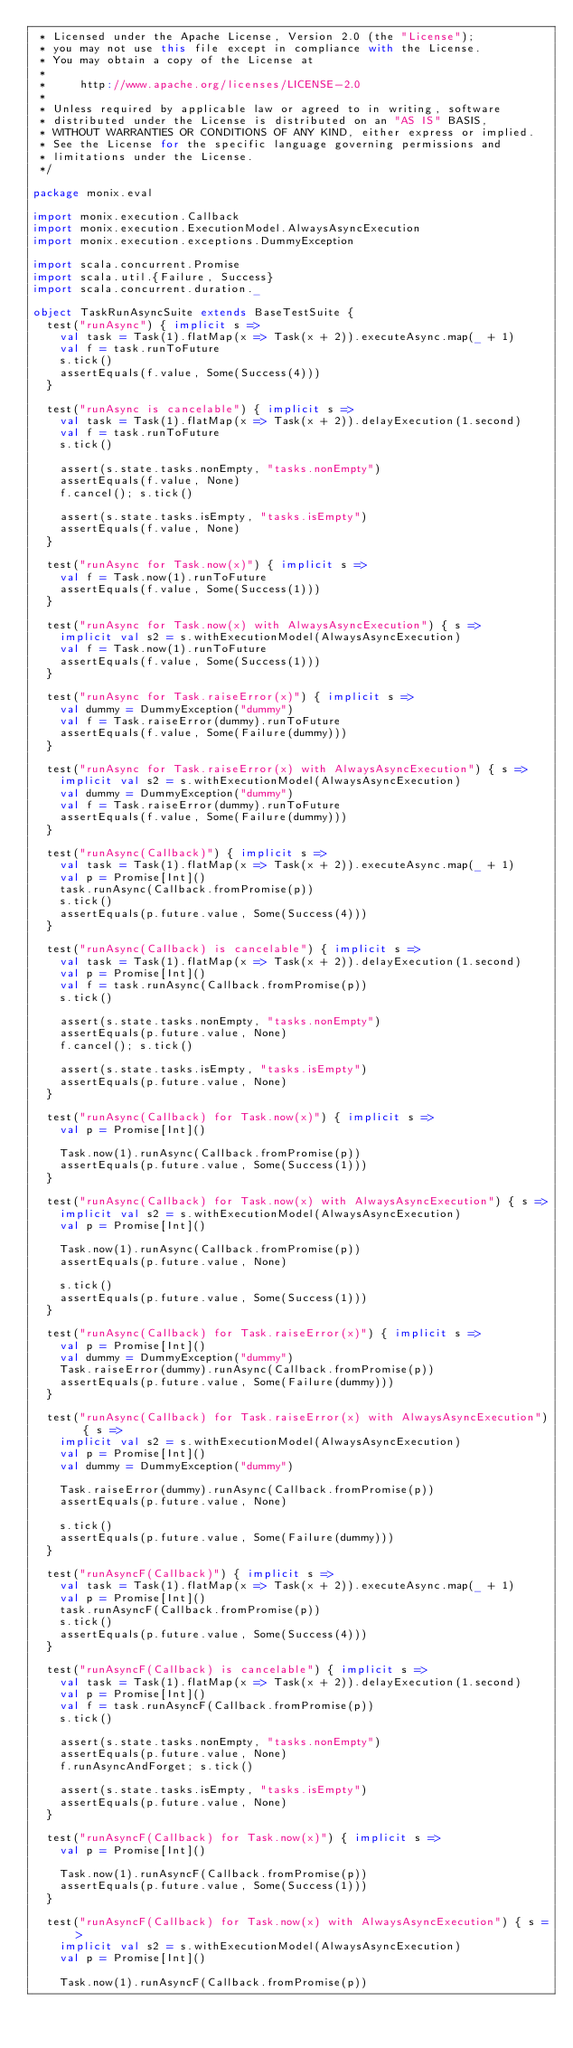Convert code to text. <code><loc_0><loc_0><loc_500><loc_500><_Scala_> * Licensed under the Apache License, Version 2.0 (the "License");
 * you may not use this file except in compliance with the License.
 * You may obtain a copy of the License at
 *
 *     http://www.apache.org/licenses/LICENSE-2.0
 *
 * Unless required by applicable law or agreed to in writing, software
 * distributed under the License is distributed on an "AS IS" BASIS,
 * WITHOUT WARRANTIES OR CONDITIONS OF ANY KIND, either express or implied.
 * See the License for the specific language governing permissions and
 * limitations under the License.
 */

package monix.eval

import monix.execution.Callback
import monix.execution.ExecutionModel.AlwaysAsyncExecution
import monix.execution.exceptions.DummyException

import scala.concurrent.Promise
import scala.util.{Failure, Success}
import scala.concurrent.duration._

object TaskRunAsyncSuite extends BaseTestSuite {
  test("runAsync") { implicit s =>
    val task = Task(1).flatMap(x => Task(x + 2)).executeAsync.map(_ + 1)
    val f = task.runToFuture
    s.tick()
    assertEquals(f.value, Some(Success(4)))
  }

  test("runAsync is cancelable") { implicit s =>
    val task = Task(1).flatMap(x => Task(x + 2)).delayExecution(1.second)
    val f = task.runToFuture
    s.tick()

    assert(s.state.tasks.nonEmpty, "tasks.nonEmpty")
    assertEquals(f.value, None)
    f.cancel(); s.tick()

    assert(s.state.tasks.isEmpty, "tasks.isEmpty")
    assertEquals(f.value, None)
  }

  test("runAsync for Task.now(x)") { implicit s =>
    val f = Task.now(1).runToFuture
    assertEquals(f.value, Some(Success(1)))
  }

  test("runAsync for Task.now(x) with AlwaysAsyncExecution") { s =>
    implicit val s2 = s.withExecutionModel(AlwaysAsyncExecution)
    val f = Task.now(1).runToFuture
    assertEquals(f.value, Some(Success(1)))
  }

  test("runAsync for Task.raiseError(x)") { implicit s =>
    val dummy = DummyException("dummy")
    val f = Task.raiseError(dummy).runToFuture
    assertEquals(f.value, Some(Failure(dummy)))
  }

  test("runAsync for Task.raiseError(x) with AlwaysAsyncExecution") { s =>
    implicit val s2 = s.withExecutionModel(AlwaysAsyncExecution)
    val dummy = DummyException("dummy")
    val f = Task.raiseError(dummy).runToFuture
    assertEquals(f.value, Some(Failure(dummy)))
  }

  test("runAsync(Callback)") { implicit s =>
    val task = Task(1).flatMap(x => Task(x + 2)).executeAsync.map(_ + 1)
    val p = Promise[Int]()
    task.runAsync(Callback.fromPromise(p))
    s.tick()
    assertEquals(p.future.value, Some(Success(4)))
  }

  test("runAsync(Callback) is cancelable") { implicit s =>
    val task = Task(1).flatMap(x => Task(x + 2)).delayExecution(1.second)
    val p = Promise[Int]()
    val f = task.runAsync(Callback.fromPromise(p))
    s.tick()

    assert(s.state.tasks.nonEmpty, "tasks.nonEmpty")
    assertEquals(p.future.value, None)
    f.cancel(); s.tick()

    assert(s.state.tasks.isEmpty, "tasks.isEmpty")
    assertEquals(p.future.value, None)
  }

  test("runAsync(Callback) for Task.now(x)") { implicit s =>
    val p = Promise[Int]()

    Task.now(1).runAsync(Callback.fromPromise(p))
    assertEquals(p.future.value, Some(Success(1)))
  }

  test("runAsync(Callback) for Task.now(x) with AlwaysAsyncExecution") { s =>
    implicit val s2 = s.withExecutionModel(AlwaysAsyncExecution)
    val p = Promise[Int]()

    Task.now(1).runAsync(Callback.fromPromise(p))
    assertEquals(p.future.value, None)

    s.tick()
    assertEquals(p.future.value, Some(Success(1)))
  }

  test("runAsync(Callback) for Task.raiseError(x)") { implicit s =>
    val p = Promise[Int]()
    val dummy = DummyException("dummy")
    Task.raiseError(dummy).runAsync(Callback.fromPromise(p))
    assertEquals(p.future.value, Some(Failure(dummy)))
  }

  test("runAsync(Callback) for Task.raiseError(x) with AlwaysAsyncExecution") { s =>
    implicit val s2 = s.withExecutionModel(AlwaysAsyncExecution)
    val p = Promise[Int]()
    val dummy = DummyException("dummy")

    Task.raiseError(dummy).runAsync(Callback.fromPromise(p))
    assertEquals(p.future.value, None)

    s.tick()
    assertEquals(p.future.value, Some(Failure(dummy)))
  }

  test("runAsyncF(Callback)") { implicit s =>
    val task = Task(1).flatMap(x => Task(x + 2)).executeAsync.map(_ + 1)
    val p = Promise[Int]()
    task.runAsyncF(Callback.fromPromise(p))
    s.tick()
    assertEquals(p.future.value, Some(Success(4)))
  }

  test("runAsyncF(Callback) is cancelable") { implicit s =>
    val task = Task(1).flatMap(x => Task(x + 2)).delayExecution(1.second)
    val p = Promise[Int]()
    val f = task.runAsyncF(Callback.fromPromise(p))
    s.tick()

    assert(s.state.tasks.nonEmpty, "tasks.nonEmpty")
    assertEquals(p.future.value, None)
    f.runAsyncAndForget; s.tick()

    assert(s.state.tasks.isEmpty, "tasks.isEmpty")
    assertEquals(p.future.value, None)
  }

  test("runAsyncF(Callback) for Task.now(x)") { implicit s =>
    val p = Promise[Int]()

    Task.now(1).runAsyncF(Callback.fromPromise(p))
    assertEquals(p.future.value, Some(Success(1)))
  }

  test("runAsyncF(Callback) for Task.now(x) with AlwaysAsyncExecution") { s =>
    implicit val s2 = s.withExecutionModel(AlwaysAsyncExecution)
    val p = Promise[Int]()

    Task.now(1).runAsyncF(Callback.fromPromise(p))</code> 